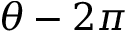Convert formula to latex. <formula><loc_0><loc_0><loc_500><loc_500>\theta - 2 \pi</formula> 